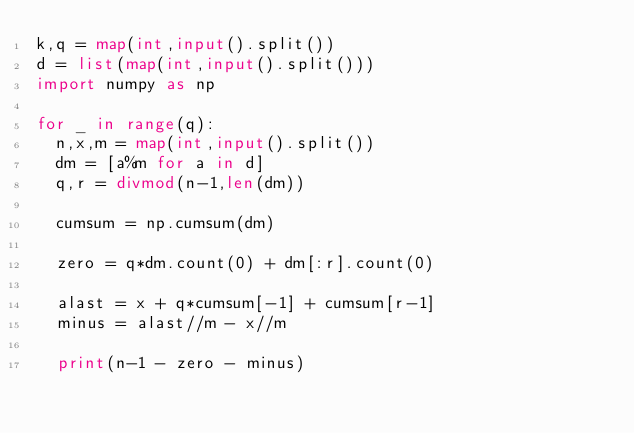<code> <loc_0><loc_0><loc_500><loc_500><_Python_>k,q = map(int,input().split())
d = list(map(int,input().split()))
import numpy as np

for _ in range(q):
  n,x,m = map(int,input().split())
  dm = [a%m for a in d]
  q,r = divmod(n-1,len(dm))
  
  cumsum = np.cumsum(dm) 
  
  zero = q*dm.count(0) + dm[:r].count(0)
  
  alast = x + q*cumsum[-1] + cumsum[r-1]
  minus = alast//m - x//m
  
  print(n-1 - zero - minus)

</code> 